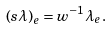<formula> <loc_0><loc_0><loc_500><loc_500>\left ( s \lambda \right ) _ { e } = w ^ { - 1 } \lambda _ { e } .</formula> 